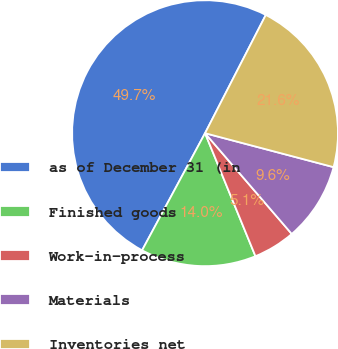Convert chart. <chart><loc_0><loc_0><loc_500><loc_500><pie_chart><fcel>as of December 31 (in<fcel>Finished goods<fcel>Work-in-process<fcel>Materials<fcel>Inventories net<nl><fcel>49.71%<fcel>14.04%<fcel>5.12%<fcel>9.58%<fcel>21.56%<nl></chart> 